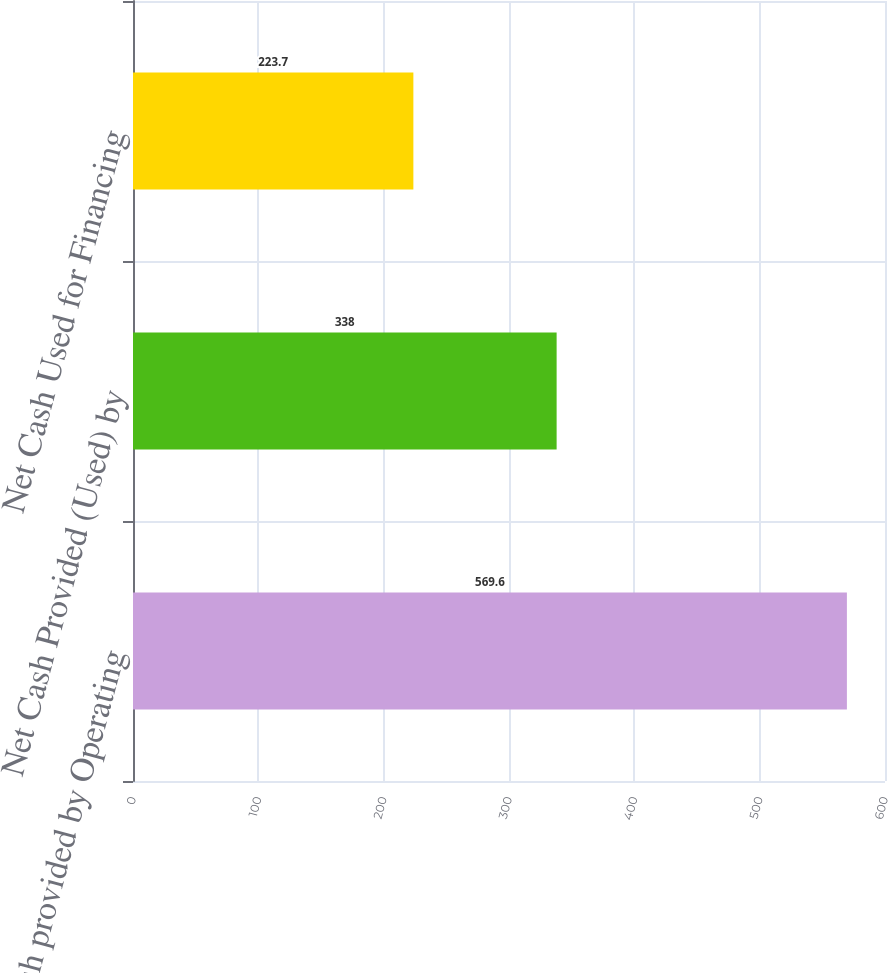Convert chart. <chart><loc_0><loc_0><loc_500><loc_500><bar_chart><fcel>Net cash provided by Operating<fcel>Net Cash Provided (Used) by<fcel>Net Cash Used for Financing<nl><fcel>569.6<fcel>338<fcel>223.7<nl></chart> 